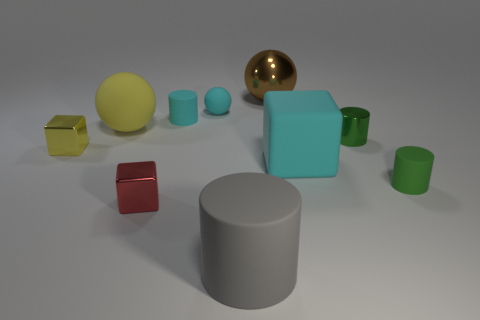What is the size of the object that is the same color as the tiny shiny cylinder?
Your answer should be very brief. Small. The green thing that is behind the tiny matte object in front of the shiny cylinder is what shape?
Provide a succinct answer. Cylinder. Do the yellow matte thing and the thing to the right of the tiny green shiny object have the same shape?
Provide a succinct answer. No. What color is the shiny thing that is the same size as the cyan block?
Offer a terse response. Brown. Are there fewer small blocks that are on the right side of the big yellow matte sphere than cyan objects behind the small red metallic object?
Your answer should be compact. Yes. There is a yellow thing that is behind the tiny green cylinder to the left of the tiny rubber object that is right of the big gray rubber cylinder; what shape is it?
Provide a succinct answer. Sphere. There is a large ball that is on the right side of the yellow rubber sphere; is its color the same as the tiny shiny block that is to the left of the large yellow rubber sphere?
Offer a terse response. No. There is a tiny matte thing that is the same color as the small sphere; what is its shape?
Make the answer very short. Cylinder. What number of matte objects are either small green objects or tiny gray balls?
Your answer should be very brief. 1. The big rubber object to the left of the rubber sphere that is on the right side of the ball on the left side of the cyan matte cylinder is what color?
Provide a short and direct response. Yellow. 